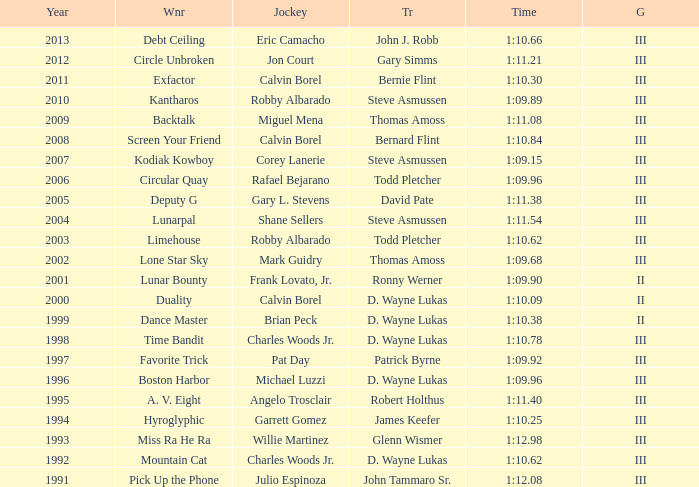Which trainer won the hyroglyphic in a year that was before 2010? James Keefer. 